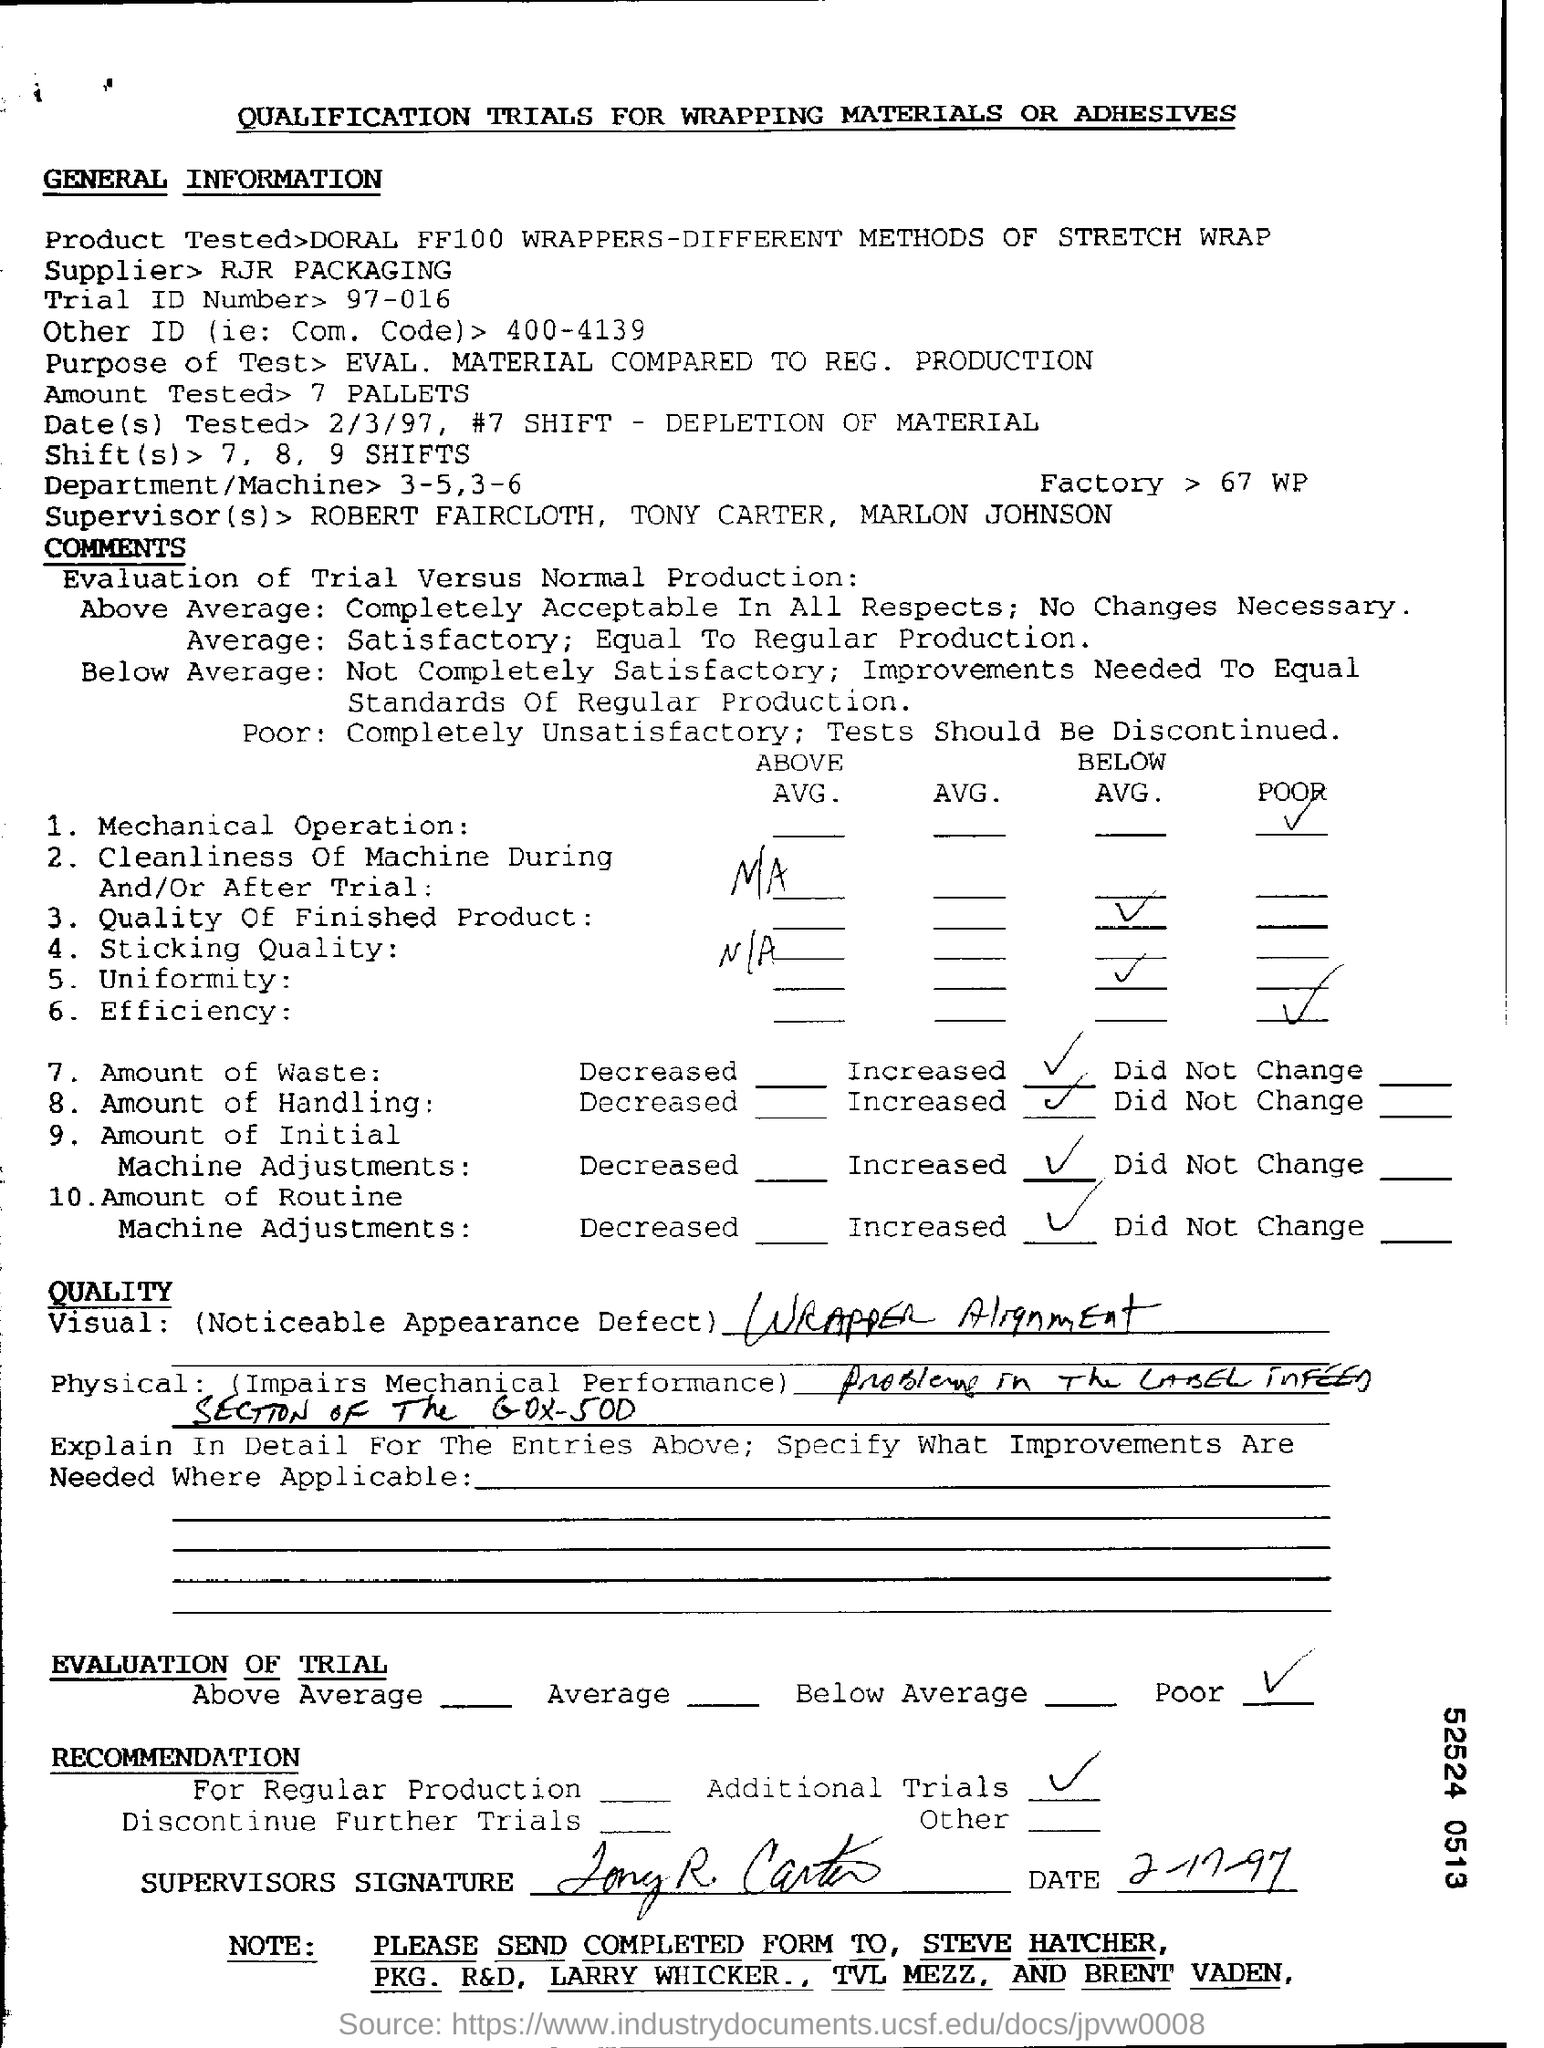What is the page title?
Provide a short and direct response. QUALIFICATION TRIALS FOR WRAPPING MATERIALS OR ADHESIVES. What is the trial id number?
Your response must be concise. 97-016. What is the amount tested?
Your answer should be very brief. 7 pallets. Who is the supplier?
Offer a very short reply. RJR Packaging. Who are the supervisors?
Your answer should be very brief. ROBERT FAIRCLOTH, TONY CARTER, MARLON JOHNSON. How is the mechanical operation?
Keep it short and to the point. POOR. Has the amount of waste increased or decreased?
Provide a short and direct response. Increased. What is recommended based on the evaluation?
Provide a succinct answer. Additional Trials. 